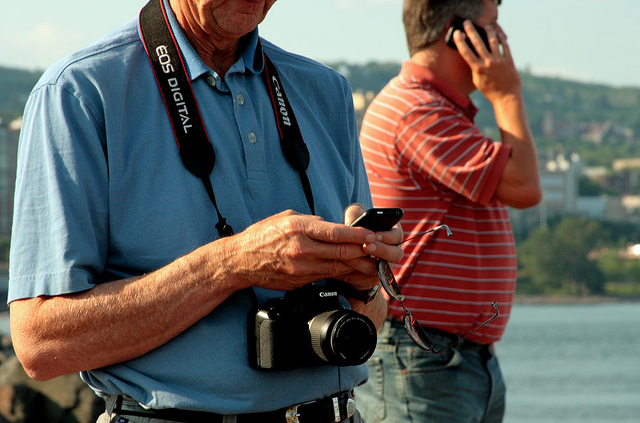What does the man do with the object around his neck? The man appears to be using a camera that is hanging around his neck, most likely to take photographs. Cameras are used to capture moments in still images, and in this case, the man seems to be focusing on his camera’s settings or previewing images he has already taken. So the correct answer, based on the options provided, is B. take photos. 